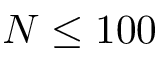<formula> <loc_0><loc_0><loc_500><loc_500>N \leq 1 0 0</formula> 